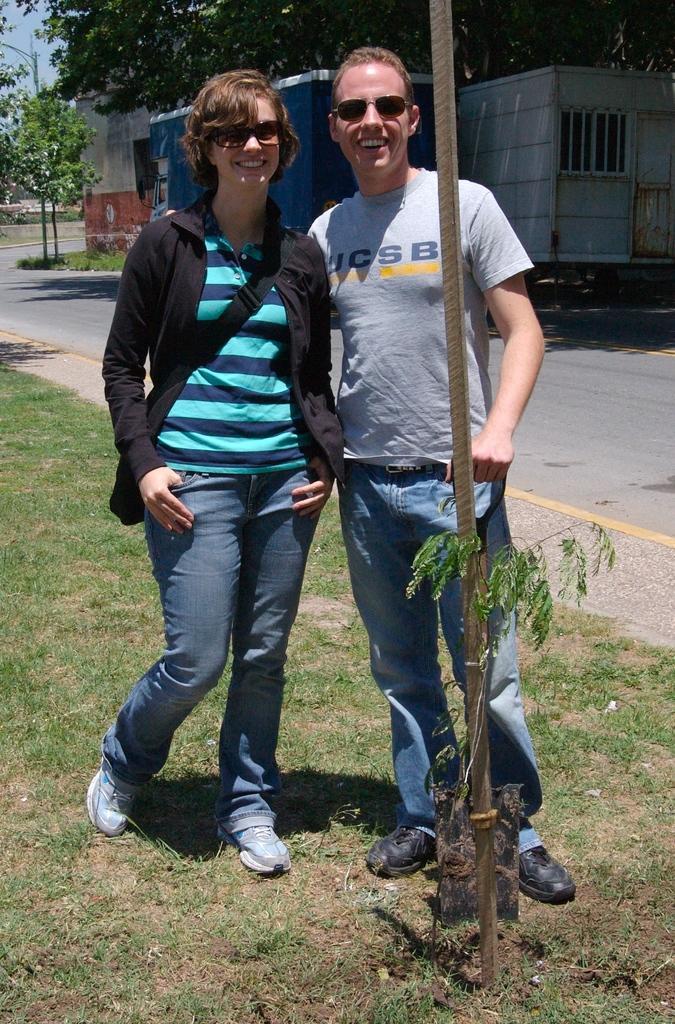Describe this image in one or two sentences. In this image there is grass at the bottom. There are leaves on the left corner. There is a wooden stick with plant and there are people standing in the foreground. There is a road on the right corner. There are vehicles, trees in the background. And there is sky at the top. 